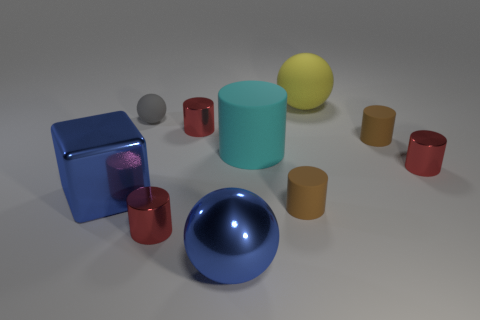Which object stands out the most and why? The large blue sphere stands out due to its bright color and size, which contrasts with the more subdued colors and smaller sizes of the surrounding objects.  If you had to guess, what material are these objects made of? Judging by the surface textures and light reflections, the objects appear to be made of various materials, including matte rubber-like textures for the cylinders and a shiny, metallic texture for the blue spherical object in the foreground. 